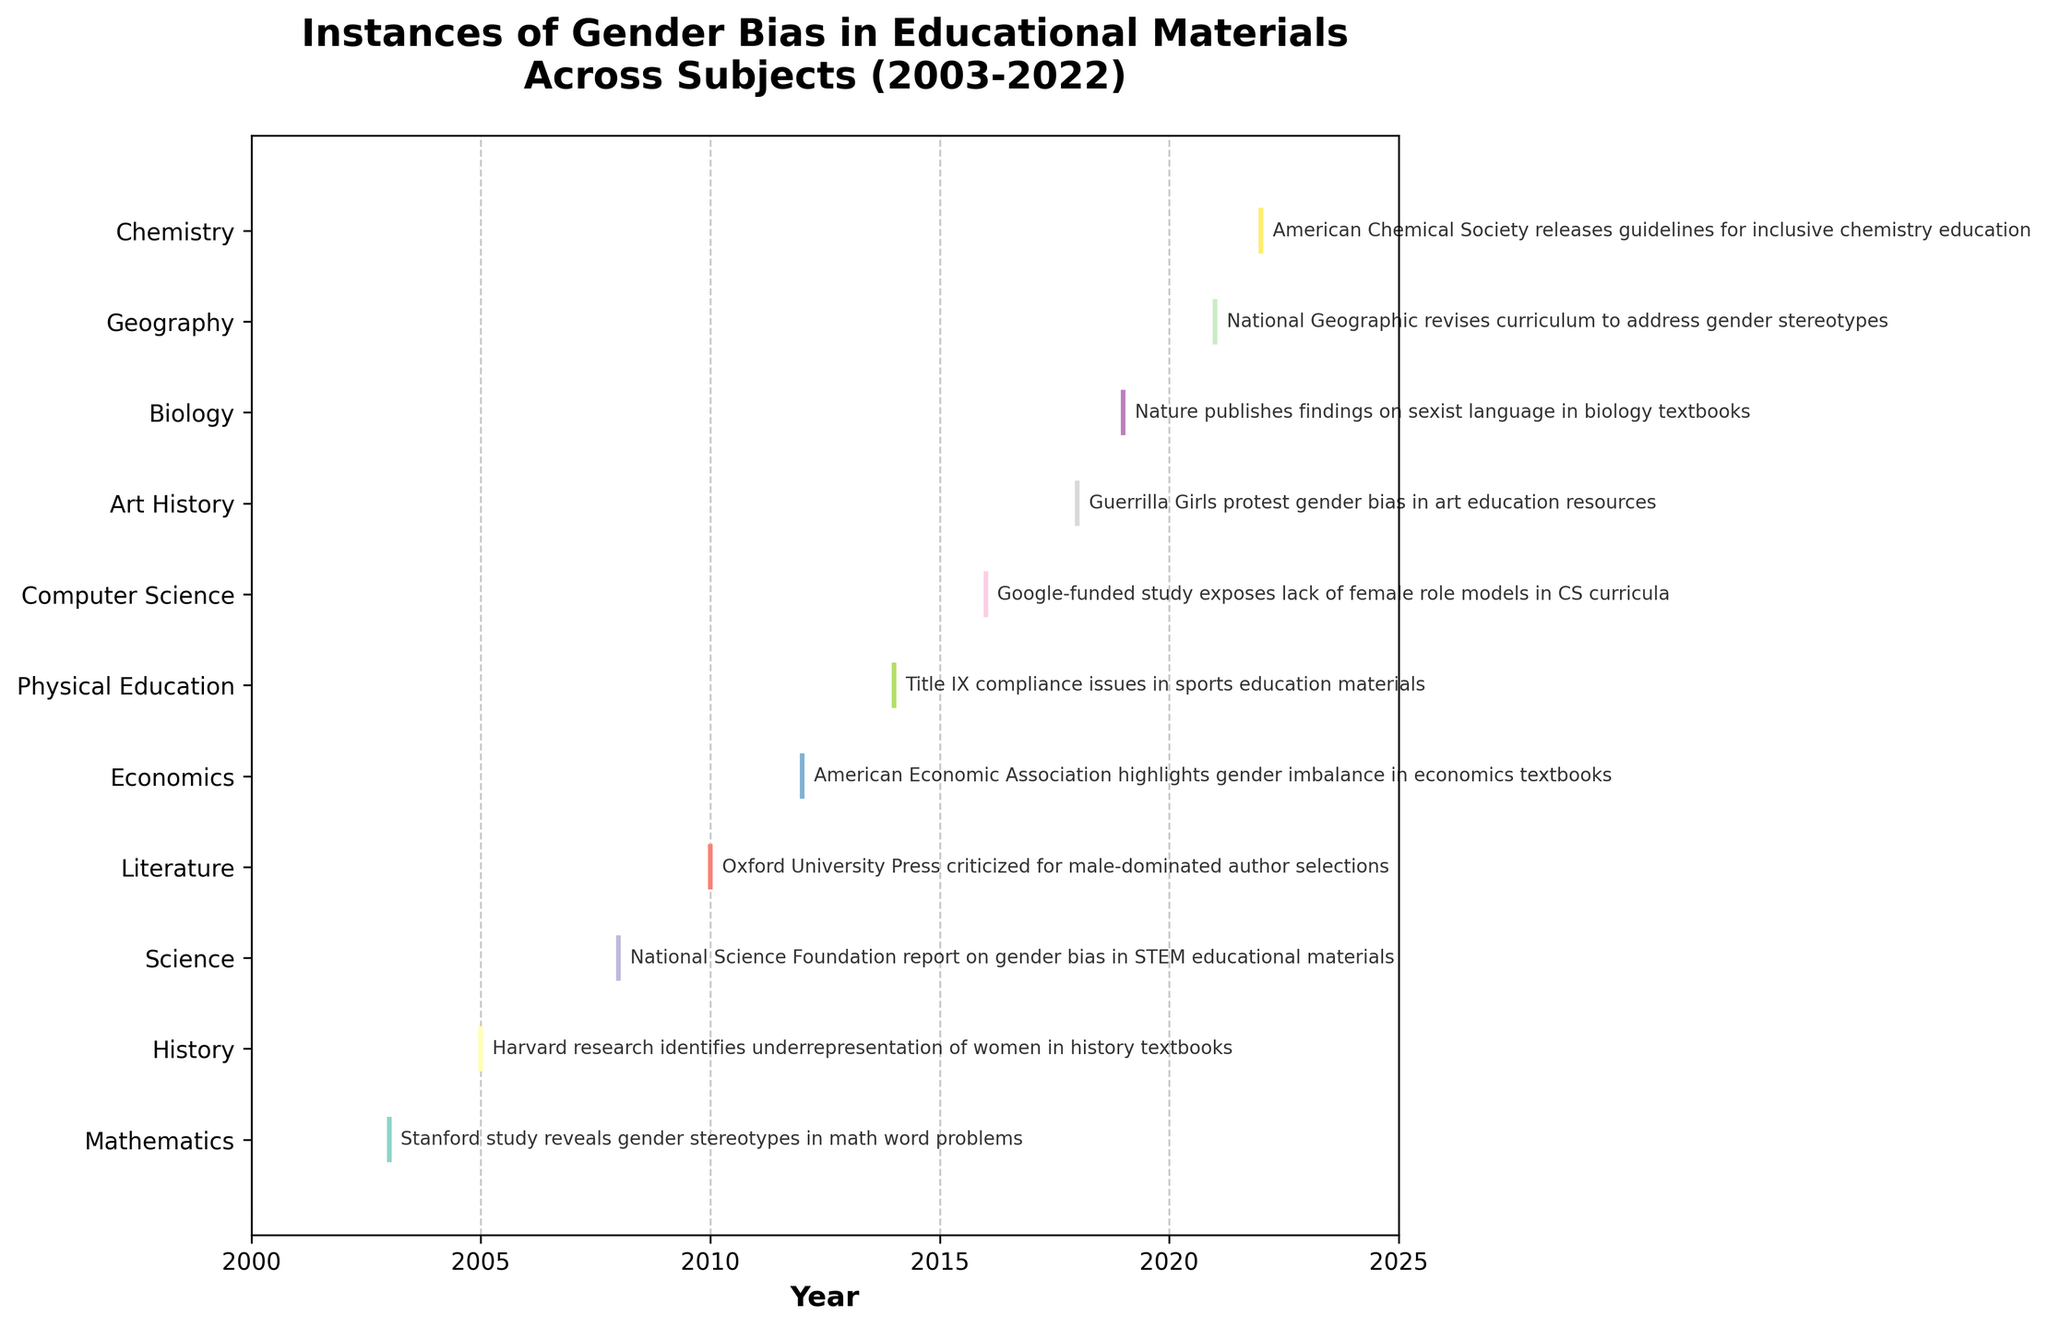What is the title of the figure? To identify the title, simply look at the top of the figure where it is written in bold text. It reads "Instances of Gender Bias in Educational Materials Across Subjects (2003-2022)".
Answer: Instances of Gender Bias in Educational Materials Across Subjects (2003-2022) Which subject has the earliest reported instance of gender bias? Locate the earliest year on the x-axis and find the corresponding subject on the y-axis. The earliest year is 2003, and the subject is Mathematics.
Answer: Mathematics How many subjects reported instances of gender bias between 2010 and 2020? To determine the number of subjects, look at the years from 2010 to 2020 on the x-axis and count the unique subjects listed on the y-axis that have events within this range. The subjects are Literature, Economics, Physical Education, Computer Science, and Art History.
Answer: 5 Which event was reported in 2016? Identify the year 2016 on the x-axis and trace vertically to find the corresponding subject and event annotation. The event in 2016 is "Google-funded study exposes lack of female role models in CS curricula" under the subject Computer Science.
Answer: Google-funded study exposes lack of female role models in CS curricula Are there more instances of gender bias reported in STEM subjects or non-STEM subjects? Identify which subjects fall under STEM (Mathematics, Science, Computer Science, Biology, Chemistry) and non-STEM (History, Literature, Economics, Physical Education, Art History, Geography). Count the events in each category. STEM: 6 (Mathematics-1, Science-1, Computer Science-1, Biology-1, Chemistry-1), Non-STEM: 6 (History-1, Literature-1, Economics-1, Physical Education-1, Art History-1, Geography-1). The numbers are equal.
Answer: Equal Which subject has the most reported instances of gender bias, and how many instances does it have? Examine the length of each eventplot line and count the events annotated for each subject. Each subject in the figure has one instance reported.
Answer: All subjects have 1 instance In which year did the subject of Art History report a gender bias event? Find "Art History" on the y-axis and look at the corresponding event along the x-axis. The year is 2018.
Answer: 2018 Which subjects reported gender bias events after 2018? Look at the years after 2018 on the x-axis and identify the subjects with events listed on the y-axis. The subjects are Biology, Geography, and Chemistry.
Answer: Biology, Geography, Chemistry What was the reported gender bias event in Biology in 2019? Locate 2019 on the x-axis and trace vertically to find the subject Biology and its event annotation. The event is "Nature publishes findings on sexist language in biology textbooks".
Answer: Nature publishes findings on sexist language in biology textbooks Compare the number of gender bias events reported between the periods 2003-2012 and 2013-2022. Which period had more events? Count the events in each period: 2003-2012 (Mathematics, History, Science, Literature, Economics) has 5 events, and 2013-2022 (Physical Education, Computer Science, Art History, Biology, Geography, Chemistry) has 6 events. The period 2013-2022 has more events.
Answer: 2013-2022 